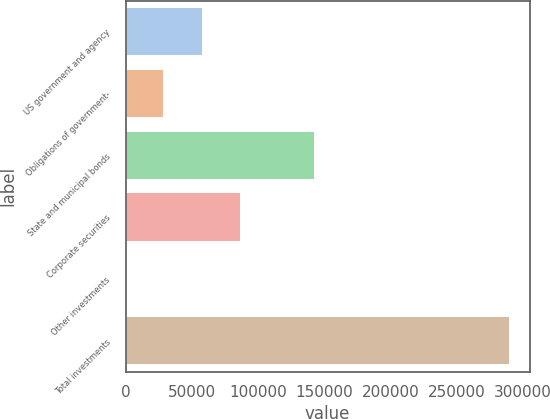Convert chart. <chart><loc_0><loc_0><loc_500><loc_500><bar_chart><fcel>US government and agency<fcel>Obligations of government-<fcel>State and municipal bonds<fcel>Corporate securities<fcel>Other investments<fcel>Total investments<nl><fcel>58084.2<fcel>29060.1<fcel>142873<fcel>87108.3<fcel>36<fcel>290277<nl></chart> 